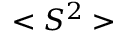<formula> <loc_0><loc_0><loc_500><loc_500>< S ^ { 2 } ></formula> 